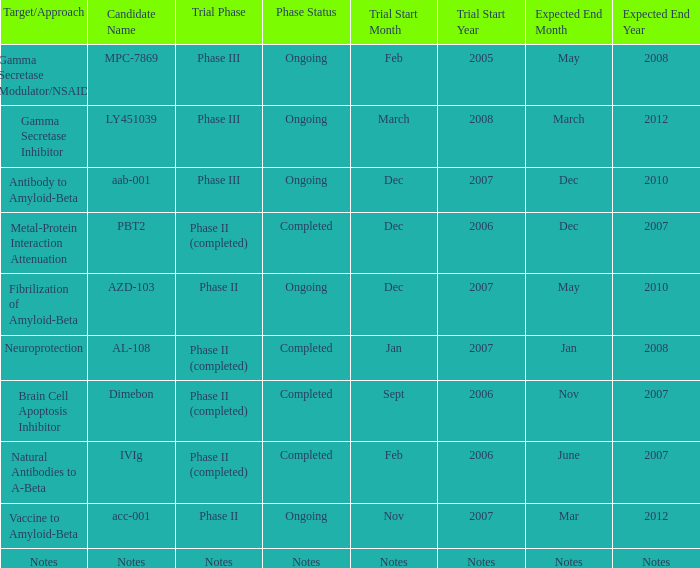When the target or approach involves a "vaccine to amyloid-beta," what is the candidate's name? Acc-001. 